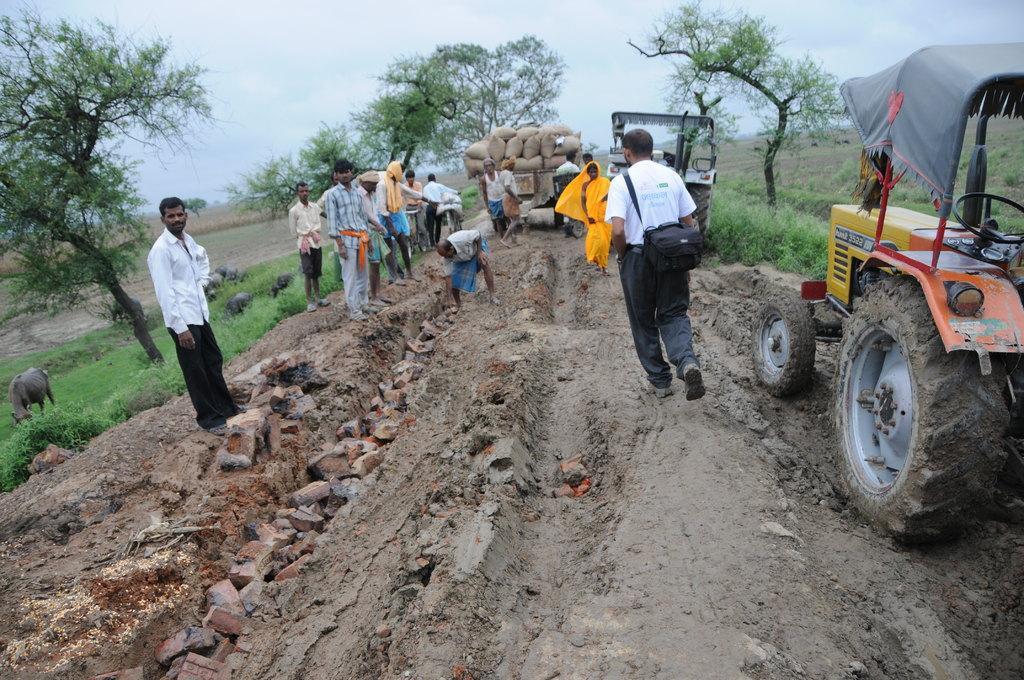Please provide a concise description of this image. In the picture we can see a muddy path with some broken bricks and beside the path we can see a tractor and on the other side, we can see some people are standing and on the other sides of the path we can see grass surface and some trees and in the background we can see a sky. 